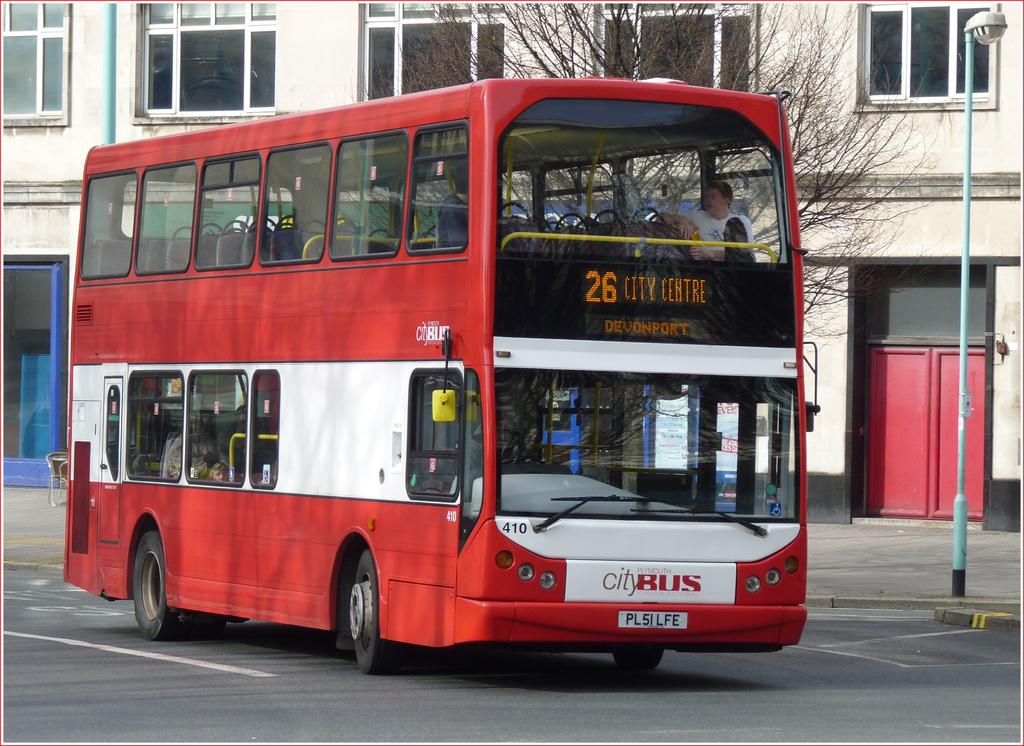<image>
Write a terse but informative summary of the picture. The Devenport 26 bus cruises up the street. 